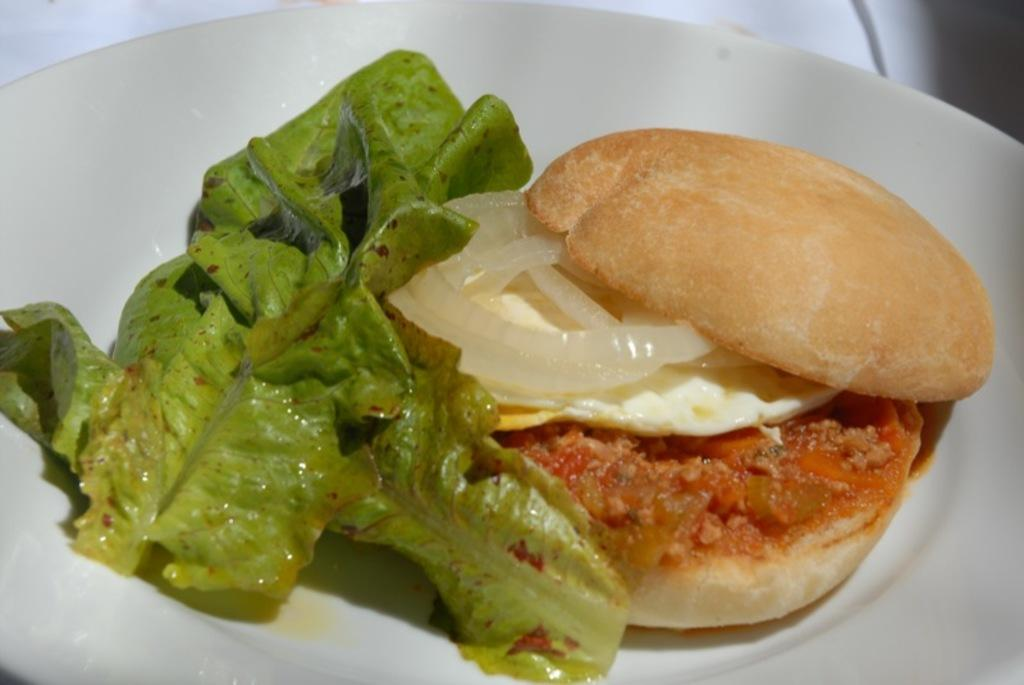What is on the plate in the image? There is a food item on a plate in the image. Can you describe any other elements in the image besides the plate and food? Yes, there is a leaf in the image. What type of art is displayed on the wall in the image? There is no mention of a wall or any art in the image; it only contains a food item on a plate and a leaf. 